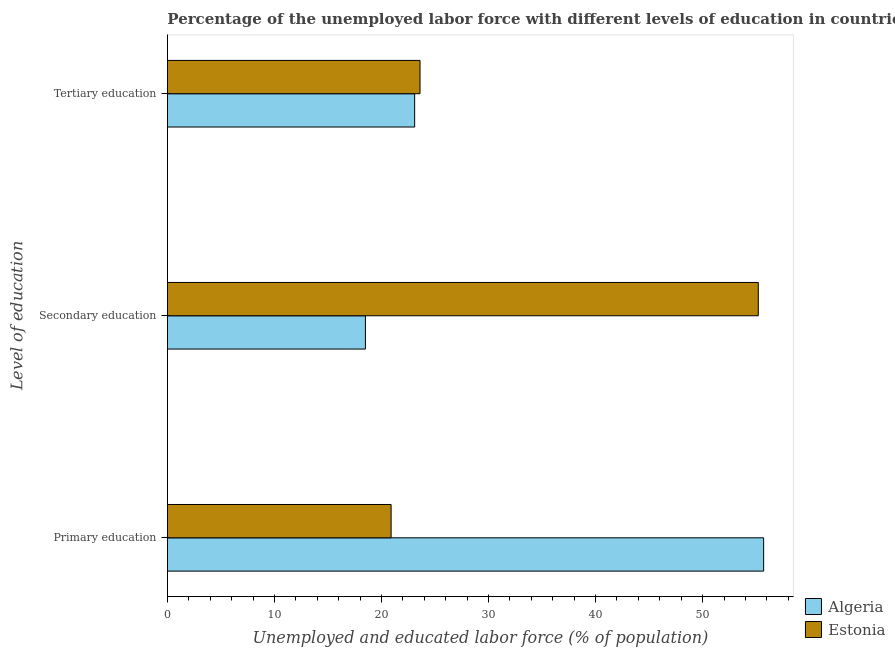How many groups of bars are there?
Keep it short and to the point. 3. Are the number of bars per tick equal to the number of legend labels?
Keep it short and to the point. Yes. Are the number of bars on each tick of the Y-axis equal?
Your answer should be compact. Yes. How many bars are there on the 3rd tick from the bottom?
Make the answer very short. 2. What is the label of the 2nd group of bars from the top?
Your answer should be compact. Secondary education. What is the percentage of labor force who received tertiary education in Algeria?
Make the answer very short. 23.1. Across all countries, what is the maximum percentage of labor force who received primary education?
Offer a very short reply. 55.7. Across all countries, what is the minimum percentage of labor force who received primary education?
Make the answer very short. 20.9. In which country was the percentage of labor force who received secondary education maximum?
Your answer should be very brief. Estonia. In which country was the percentage of labor force who received primary education minimum?
Your answer should be compact. Estonia. What is the total percentage of labor force who received secondary education in the graph?
Provide a short and direct response. 73.7. What is the difference between the percentage of labor force who received tertiary education in Algeria and that in Estonia?
Ensure brevity in your answer.  -0.5. What is the difference between the percentage of labor force who received primary education in Estonia and the percentage of labor force who received secondary education in Algeria?
Keep it short and to the point. 2.4. What is the average percentage of labor force who received primary education per country?
Ensure brevity in your answer.  38.3. What is the difference between the percentage of labor force who received primary education and percentage of labor force who received tertiary education in Algeria?
Give a very brief answer. 32.6. What is the ratio of the percentage of labor force who received primary education in Algeria to that in Estonia?
Your response must be concise. 2.67. Is the percentage of labor force who received tertiary education in Algeria less than that in Estonia?
Your response must be concise. Yes. What is the difference between the highest and the lowest percentage of labor force who received primary education?
Provide a succinct answer. 34.8. Is the sum of the percentage of labor force who received tertiary education in Estonia and Algeria greater than the maximum percentage of labor force who received primary education across all countries?
Keep it short and to the point. No. What does the 1st bar from the top in Primary education represents?
Your answer should be compact. Estonia. What does the 2nd bar from the bottom in Tertiary education represents?
Your answer should be very brief. Estonia. How many bars are there?
Keep it short and to the point. 6. Are all the bars in the graph horizontal?
Keep it short and to the point. Yes. What is the difference between two consecutive major ticks on the X-axis?
Make the answer very short. 10. Does the graph contain any zero values?
Your answer should be compact. No. Does the graph contain grids?
Give a very brief answer. No. Where does the legend appear in the graph?
Provide a succinct answer. Bottom right. How are the legend labels stacked?
Your answer should be compact. Vertical. What is the title of the graph?
Your answer should be very brief. Percentage of the unemployed labor force with different levels of education in countries. Does "Bulgaria" appear as one of the legend labels in the graph?
Your response must be concise. No. What is the label or title of the X-axis?
Your answer should be compact. Unemployed and educated labor force (% of population). What is the label or title of the Y-axis?
Your answer should be compact. Level of education. What is the Unemployed and educated labor force (% of population) of Algeria in Primary education?
Provide a succinct answer. 55.7. What is the Unemployed and educated labor force (% of population) of Estonia in Primary education?
Offer a terse response. 20.9. What is the Unemployed and educated labor force (% of population) of Algeria in Secondary education?
Provide a short and direct response. 18.5. What is the Unemployed and educated labor force (% of population) in Estonia in Secondary education?
Give a very brief answer. 55.2. What is the Unemployed and educated labor force (% of population) of Algeria in Tertiary education?
Provide a succinct answer. 23.1. What is the Unemployed and educated labor force (% of population) of Estonia in Tertiary education?
Ensure brevity in your answer.  23.6. Across all Level of education, what is the maximum Unemployed and educated labor force (% of population) in Algeria?
Your answer should be very brief. 55.7. Across all Level of education, what is the maximum Unemployed and educated labor force (% of population) in Estonia?
Your answer should be very brief. 55.2. Across all Level of education, what is the minimum Unemployed and educated labor force (% of population) of Algeria?
Your answer should be compact. 18.5. Across all Level of education, what is the minimum Unemployed and educated labor force (% of population) of Estonia?
Offer a very short reply. 20.9. What is the total Unemployed and educated labor force (% of population) of Algeria in the graph?
Offer a very short reply. 97.3. What is the total Unemployed and educated labor force (% of population) of Estonia in the graph?
Your answer should be very brief. 99.7. What is the difference between the Unemployed and educated labor force (% of population) of Algeria in Primary education and that in Secondary education?
Give a very brief answer. 37.2. What is the difference between the Unemployed and educated labor force (% of population) in Estonia in Primary education and that in Secondary education?
Offer a terse response. -34.3. What is the difference between the Unemployed and educated labor force (% of population) of Algeria in Primary education and that in Tertiary education?
Keep it short and to the point. 32.6. What is the difference between the Unemployed and educated labor force (% of population) in Estonia in Secondary education and that in Tertiary education?
Keep it short and to the point. 31.6. What is the difference between the Unemployed and educated labor force (% of population) of Algeria in Primary education and the Unemployed and educated labor force (% of population) of Estonia in Tertiary education?
Give a very brief answer. 32.1. What is the difference between the Unemployed and educated labor force (% of population) in Algeria in Secondary education and the Unemployed and educated labor force (% of population) in Estonia in Tertiary education?
Your answer should be compact. -5.1. What is the average Unemployed and educated labor force (% of population) in Algeria per Level of education?
Your answer should be compact. 32.43. What is the average Unemployed and educated labor force (% of population) in Estonia per Level of education?
Offer a terse response. 33.23. What is the difference between the Unemployed and educated labor force (% of population) in Algeria and Unemployed and educated labor force (% of population) in Estonia in Primary education?
Offer a terse response. 34.8. What is the difference between the Unemployed and educated labor force (% of population) in Algeria and Unemployed and educated labor force (% of population) in Estonia in Secondary education?
Offer a terse response. -36.7. What is the difference between the Unemployed and educated labor force (% of population) of Algeria and Unemployed and educated labor force (% of population) of Estonia in Tertiary education?
Your answer should be compact. -0.5. What is the ratio of the Unemployed and educated labor force (% of population) in Algeria in Primary education to that in Secondary education?
Provide a succinct answer. 3.01. What is the ratio of the Unemployed and educated labor force (% of population) of Estonia in Primary education to that in Secondary education?
Provide a short and direct response. 0.38. What is the ratio of the Unemployed and educated labor force (% of population) in Algeria in Primary education to that in Tertiary education?
Ensure brevity in your answer.  2.41. What is the ratio of the Unemployed and educated labor force (% of population) in Estonia in Primary education to that in Tertiary education?
Give a very brief answer. 0.89. What is the ratio of the Unemployed and educated labor force (% of population) of Algeria in Secondary education to that in Tertiary education?
Your answer should be very brief. 0.8. What is the ratio of the Unemployed and educated labor force (% of population) of Estonia in Secondary education to that in Tertiary education?
Offer a terse response. 2.34. What is the difference between the highest and the second highest Unemployed and educated labor force (% of population) of Algeria?
Give a very brief answer. 32.6. What is the difference between the highest and the second highest Unemployed and educated labor force (% of population) of Estonia?
Give a very brief answer. 31.6. What is the difference between the highest and the lowest Unemployed and educated labor force (% of population) in Algeria?
Give a very brief answer. 37.2. What is the difference between the highest and the lowest Unemployed and educated labor force (% of population) of Estonia?
Your answer should be very brief. 34.3. 